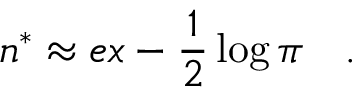<formula> <loc_0><loc_0><loc_500><loc_500>n ^ { * } \approx e x - \frac { 1 } { 2 } \log \pi \quad .</formula> 